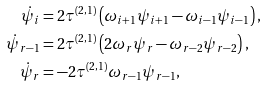<formula> <loc_0><loc_0><loc_500><loc_500>\dot { \psi } _ { i } & = 2 \tau ^ { ( 2 , 1 ) } \left ( \omega _ { i + 1 } \psi _ { i + 1 } - \omega _ { i - 1 } \psi _ { i - 1 } \right ) , \\ \dot { \psi } _ { r - 1 } & = 2 \tau ^ { ( 2 , 1 ) } \left ( 2 \omega _ { r } \psi _ { r } - \omega _ { r - 2 } \psi _ { r - 2 } \right ) , \\ \dot { \psi } _ { r } & = - 2 \tau ^ { ( 2 , 1 ) } \omega _ { r - 1 } \psi _ { r - 1 } ,</formula> 